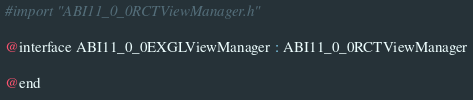<code> <loc_0><loc_0><loc_500><loc_500><_C_>#import "ABI11_0_0RCTViewManager.h"

@interface ABI11_0_0EXGLViewManager : ABI11_0_0RCTViewManager

@end
</code> 